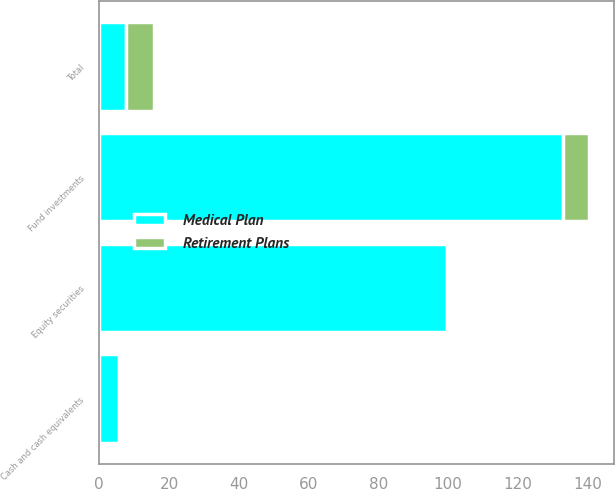<chart> <loc_0><loc_0><loc_500><loc_500><stacked_bar_chart><ecel><fcel>Cash and cash equivalents<fcel>Fund investments<fcel>Equity securities<fcel>Total<nl><fcel>Medical Plan<fcel>5.8<fcel>132.9<fcel>99.6<fcel>7.6<nl><fcel>Retirement Plans<fcel>0.3<fcel>7.6<fcel>0.2<fcel>8.1<nl></chart> 